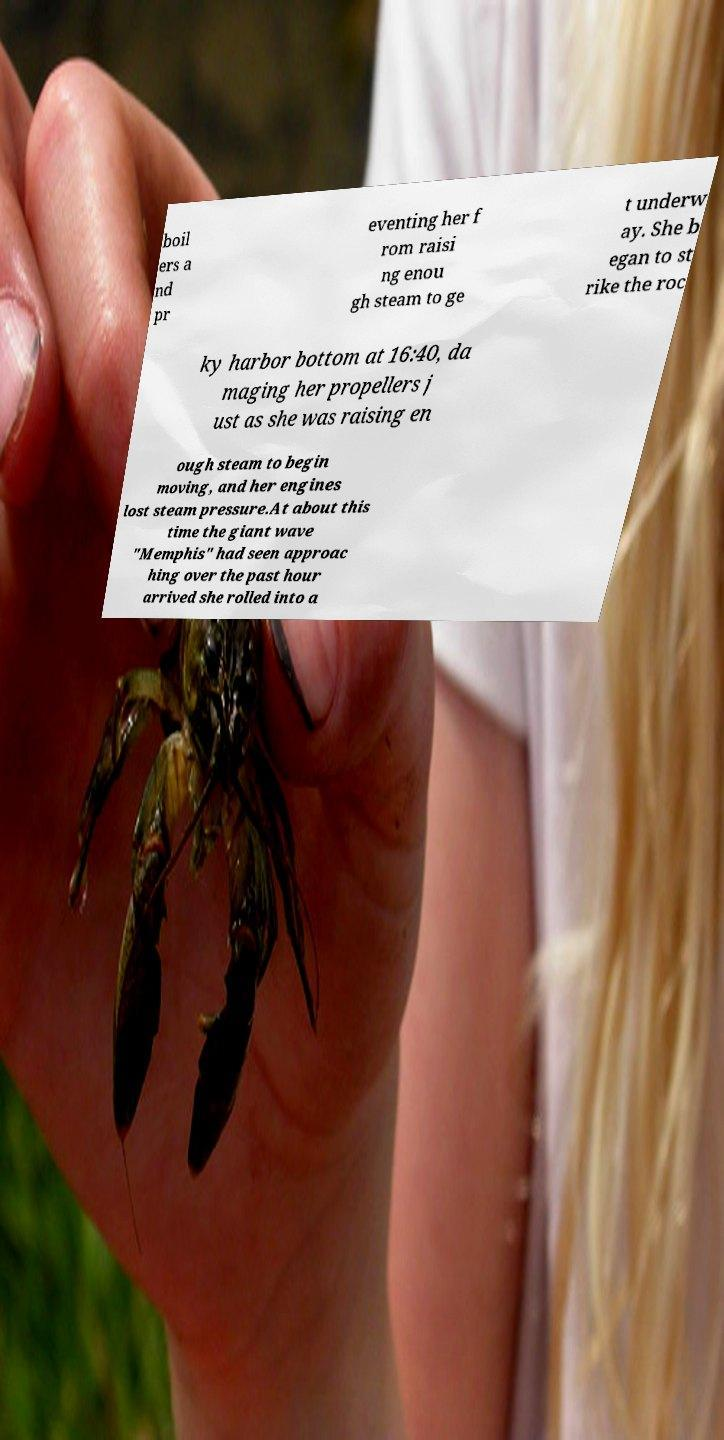Could you extract and type out the text from this image? boil ers a nd pr eventing her f rom raisi ng enou gh steam to ge t underw ay. She b egan to st rike the roc ky harbor bottom at 16:40, da maging her propellers j ust as she was raising en ough steam to begin moving, and her engines lost steam pressure.At about this time the giant wave "Memphis" had seen approac hing over the past hour arrived she rolled into a 